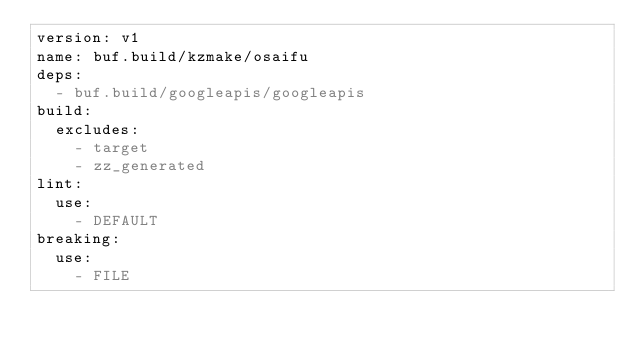Convert code to text. <code><loc_0><loc_0><loc_500><loc_500><_YAML_>version: v1
name: buf.build/kzmake/osaifu
deps:
  - buf.build/googleapis/googleapis
build:
  excludes:
    - target
    - zz_generated
lint:
  use:
    - DEFAULT
breaking:
  use:
    - FILE
</code> 